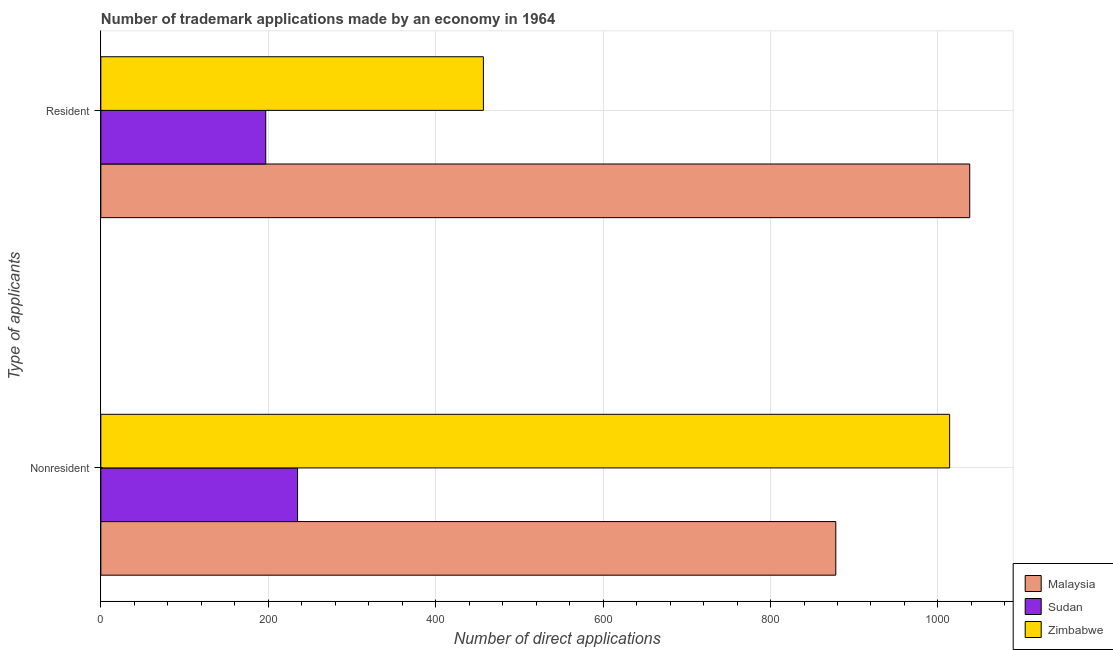How many bars are there on the 2nd tick from the bottom?
Your answer should be very brief. 3. What is the label of the 2nd group of bars from the top?
Your answer should be very brief. Nonresident. What is the number of trademark applications made by residents in Malaysia?
Provide a short and direct response. 1038. Across all countries, what is the maximum number of trademark applications made by non residents?
Ensure brevity in your answer.  1014. Across all countries, what is the minimum number of trademark applications made by non residents?
Your answer should be compact. 235. In which country was the number of trademark applications made by non residents maximum?
Provide a succinct answer. Zimbabwe. In which country was the number of trademark applications made by non residents minimum?
Your response must be concise. Sudan. What is the total number of trademark applications made by residents in the graph?
Offer a very short reply. 1692. What is the difference between the number of trademark applications made by residents in Sudan and that in Malaysia?
Provide a succinct answer. -841. What is the difference between the number of trademark applications made by residents in Sudan and the number of trademark applications made by non residents in Malaysia?
Keep it short and to the point. -681. What is the average number of trademark applications made by non residents per country?
Offer a very short reply. 709. What is the difference between the number of trademark applications made by residents and number of trademark applications made by non residents in Zimbabwe?
Your response must be concise. -557. What is the ratio of the number of trademark applications made by non residents in Zimbabwe to that in Malaysia?
Your answer should be compact. 1.15. What does the 2nd bar from the top in Resident represents?
Your answer should be very brief. Sudan. What does the 3rd bar from the bottom in Resident represents?
Offer a terse response. Zimbabwe. Are all the bars in the graph horizontal?
Give a very brief answer. Yes. How many countries are there in the graph?
Your answer should be compact. 3. What is the difference between two consecutive major ticks on the X-axis?
Ensure brevity in your answer.  200. Does the graph contain grids?
Ensure brevity in your answer.  Yes. Where does the legend appear in the graph?
Keep it short and to the point. Bottom right. How many legend labels are there?
Provide a short and direct response. 3. What is the title of the graph?
Your answer should be compact. Number of trademark applications made by an economy in 1964. What is the label or title of the X-axis?
Keep it short and to the point. Number of direct applications. What is the label or title of the Y-axis?
Your answer should be compact. Type of applicants. What is the Number of direct applications of Malaysia in Nonresident?
Your answer should be compact. 878. What is the Number of direct applications in Sudan in Nonresident?
Give a very brief answer. 235. What is the Number of direct applications in Zimbabwe in Nonresident?
Offer a terse response. 1014. What is the Number of direct applications in Malaysia in Resident?
Your answer should be very brief. 1038. What is the Number of direct applications in Sudan in Resident?
Ensure brevity in your answer.  197. What is the Number of direct applications of Zimbabwe in Resident?
Make the answer very short. 457. Across all Type of applicants, what is the maximum Number of direct applications of Malaysia?
Your response must be concise. 1038. Across all Type of applicants, what is the maximum Number of direct applications in Sudan?
Your answer should be compact. 235. Across all Type of applicants, what is the maximum Number of direct applications of Zimbabwe?
Your response must be concise. 1014. Across all Type of applicants, what is the minimum Number of direct applications in Malaysia?
Ensure brevity in your answer.  878. Across all Type of applicants, what is the minimum Number of direct applications of Sudan?
Your response must be concise. 197. Across all Type of applicants, what is the minimum Number of direct applications of Zimbabwe?
Ensure brevity in your answer.  457. What is the total Number of direct applications in Malaysia in the graph?
Offer a terse response. 1916. What is the total Number of direct applications of Sudan in the graph?
Your answer should be very brief. 432. What is the total Number of direct applications of Zimbabwe in the graph?
Your answer should be compact. 1471. What is the difference between the Number of direct applications in Malaysia in Nonresident and that in Resident?
Provide a short and direct response. -160. What is the difference between the Number of direct applications of Zimbabwe in Nonresident and that in Resident?
Your answer should be very brief. 557. What is the difference between the Number of direct applications in Malaysia in Nonresident and the Number of direct applications in Sudan in Resident?
Keep it short and to the point. 681. What is the difference between the Number of direct applications in Malaysia in Nonresident and the Number of direct applications in Zimbabwe in Resident?
Give a very brief answer. 421. What is the difference between the Number of direct applications of Sudan in Nonresident and the Number of direct applications of Zimbabwe in Resident?
Make the answer very short. -222. What is the average Number of direct applications in Malaysia per Type of applicants?
Give a very brief answer. 958. What is the average Number of direct applications in Sudan per Type of applicants?
Your response must be concise. 216. What is the average Number of direct applications in Zimbabwe per Type of applicants?
Provide a succinct answer. 735.5. What is the difference between the Number of direct applications of Malaysia and Number of direct applications of Sudan in Nonresident?
Ensure brevity in your answer.  643. What is the difference between the Number of direct applications of Malaysia and Number of direct applications of Zimbabwe in Nonresident?
Your response must be concise. -136. What is the difference between the Number of direct applications of Sudan and Number of direct applications of Zimbabwe in Nonresident?
Offer a terse response. -779. What is the difference between the Number of direct applications of Malaysia and Number of direct applications of Sudan in Resident?
Ensure brevity in your answer.  841. What is the difference between the Number of direct applications of Malaysia and Number of direct applications of Zimbabwe in Resident?
Make the answer very short. 581. What is the difference between the Number of direct applications in Sudan and Number of direct applications in Zimbabwe in Resident?
Keep it short and to the point. -260. What is the ratio of the Number of direct applications of Malaysia in Nonresident to that in Resident?
Provide a short and direct response. 0.85. What is the ratio of the Number of direct applications of Sudan in Nonresident to that in Resident?
Provide a short and direct response. 1.19. What is the ratio of the Number of direct applications of Zimbabwe in Nonresident to that in Resident?
Make the answer very short. 2.22. What is the difference between the highest and the second highest Number of direct applications in Malaysia?
Your answer should be very brief. 160. What is the difference between the highest and the second highest Number of direct applications of Sudan?
Provide a short and direct response. 38. What is the difference between the highest and the second highest Number of direct applications of Zimbabwe?
Your answer should be very brief. 557. What is the difference between the highest and the lowest Number of direct applications of Malaysia?
Provide a short and direct response. 160. What is the difference between the highest and the lowest Number of direct applications in Sudan?
Offer a terse response. 38. What is the difference between the highest and the lowest Number of direct applications of Zimbabwe?
Your answer should be compact. 557. 